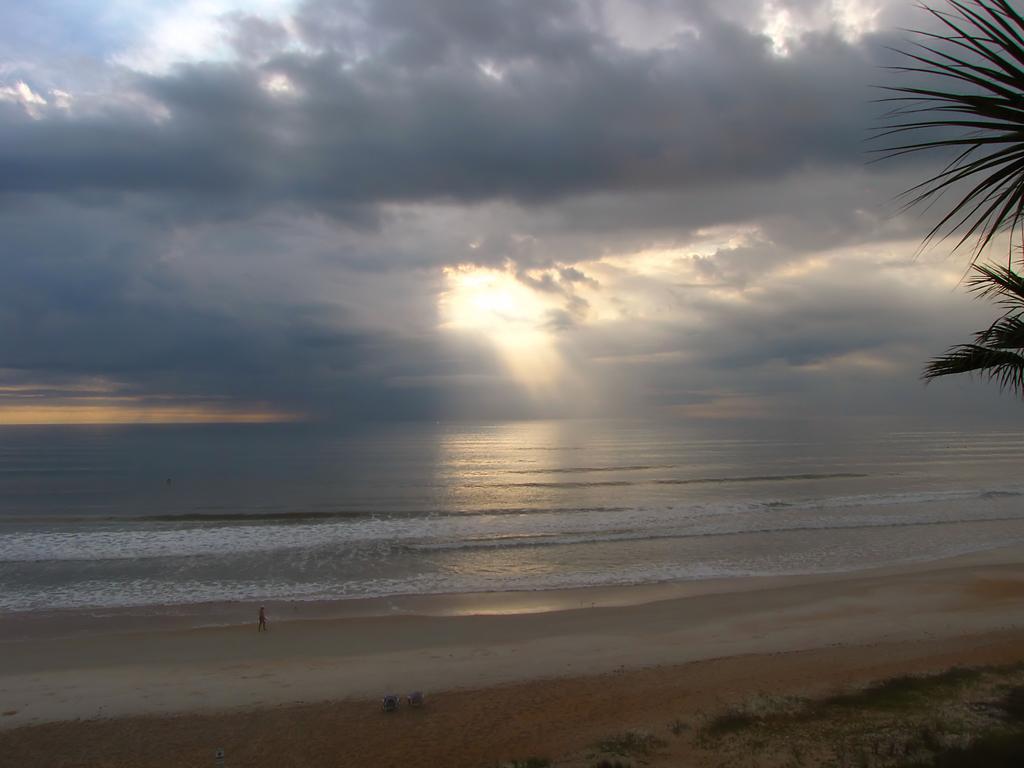Could you give a brief overview of what you see in this image? In this image I can see ground, water, a tree, clouds and the sky. I can also see a person is standing over there. 